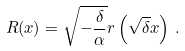<formula> <loc_0><loc_0><loc_500><loc_500>R ( x ) = \sqrt { - \frac { \delta } { \alpha } } r \left ( \sqrt { \delta } x \right ) \, .</formula> 